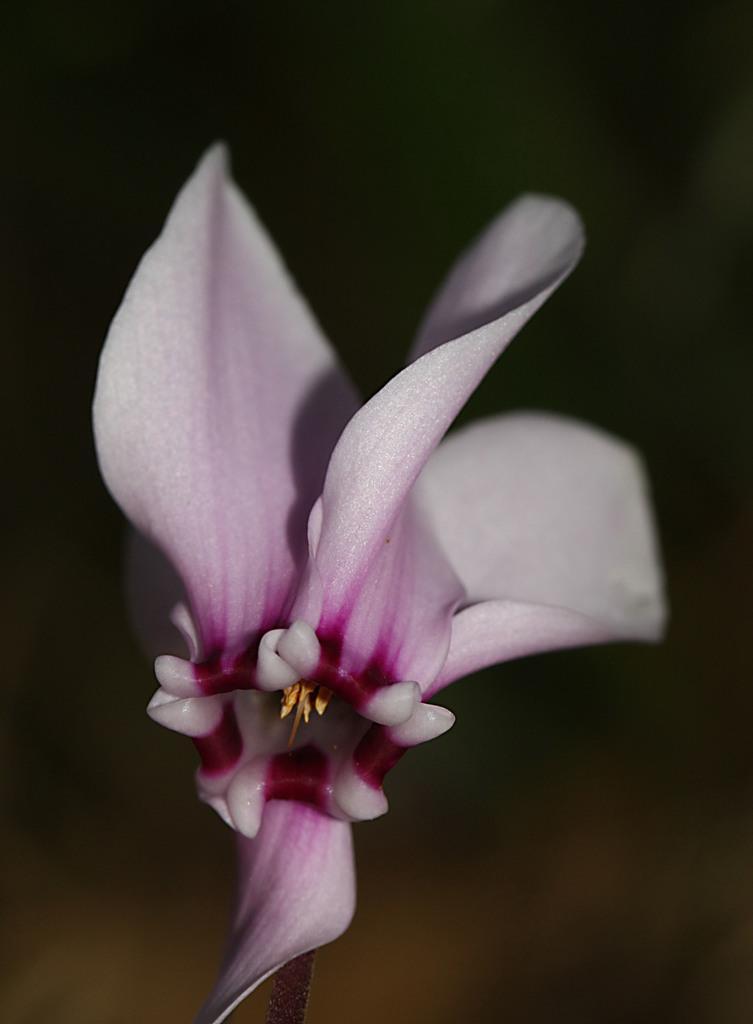In one or two sentences, can you explain what this image depicts? In this image we can see a flower and name of the flower is cattleya. 